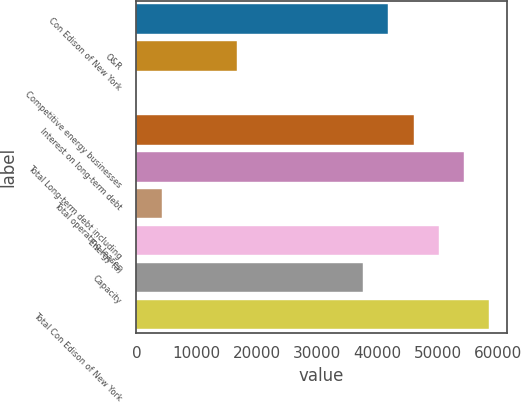Convert chart. <chart><loc_0><loc_0><loc_500><loc_500><bar_chart><fcel>Con Edison of New York<fcel>O&R<fcel>Competitive energy businesses<fcel>Interest on long-term debt<fcel>Total Long-term debt including<fcel>Total operating leases<fcel>Energy (a)<fcel>Capacity<fcel>Total Con Edison of New York<nl><fcel>41779<fcel>16717.6<fcel>10<fcel>45955.9<fcel>54309.7<fcel>4186.9<fcel>50132.8<fcel>37602.1<fcel>58486.6<nl></chart> 